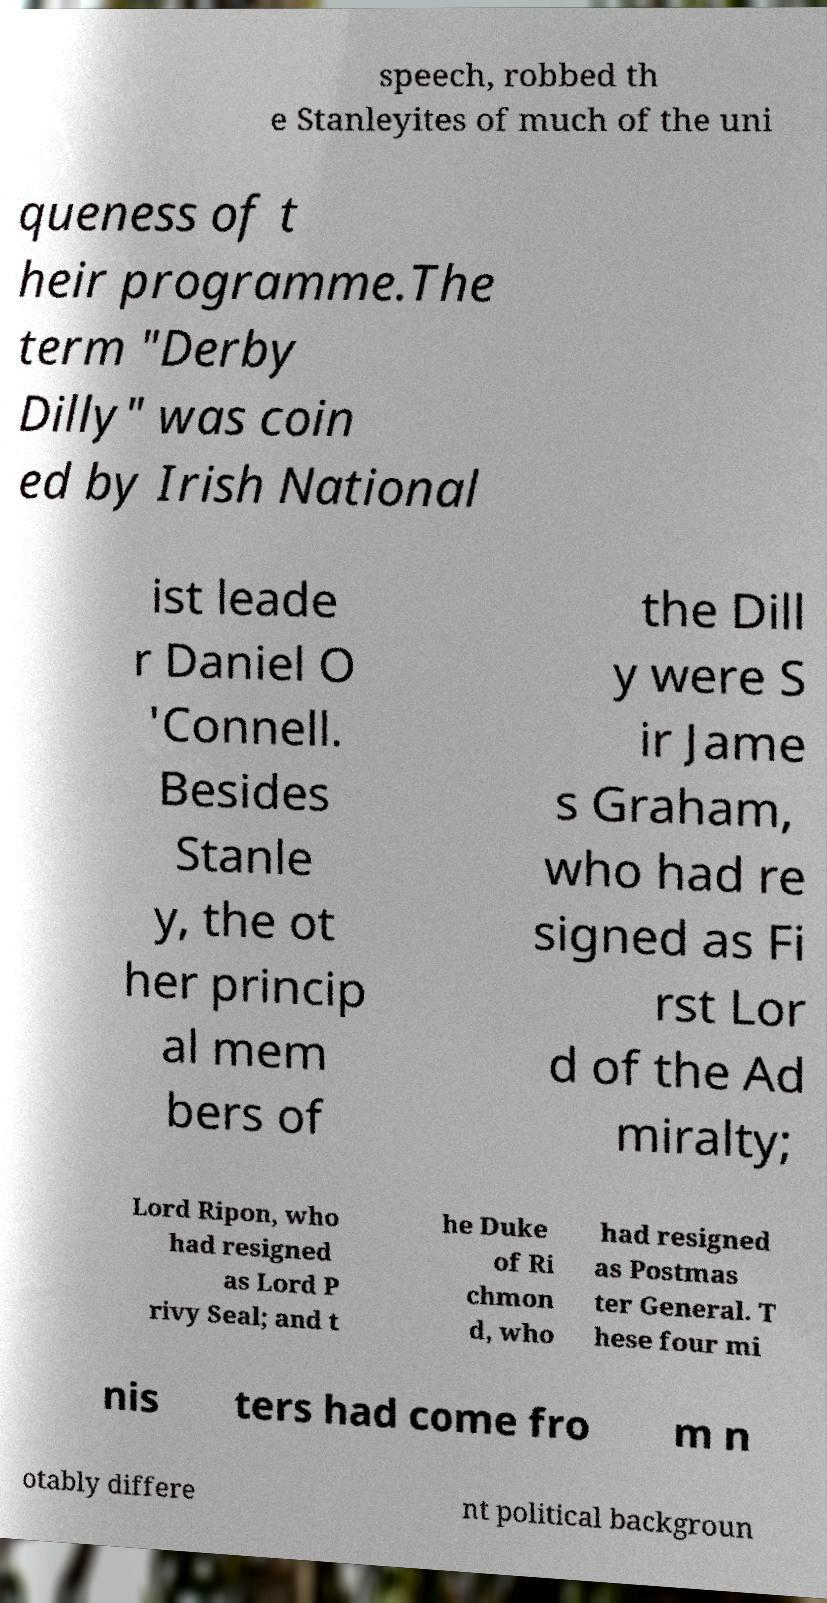What messages or text are displayed in this image? I need them in a readable, typed format. speech, robbed th e Stanleyites of much of the uni queness of t heir programme.The term "Derby Dilly" was coin ed by Irish National ist leade r Daniel O 'Connell. Besides Stanle y, the ot her princip al mem bers of the Dill y were S ir Jame s Graham, who had re signed as Fi rst Lor d of the Ad miralty; Lord Ripon, who had resigned as Lord P rivy Seal; and t he Duke of Ri chmon d, who had resigned as Postmas ter General. T hese four mi nis ters had come fro m n otably differe nt political backgroun 